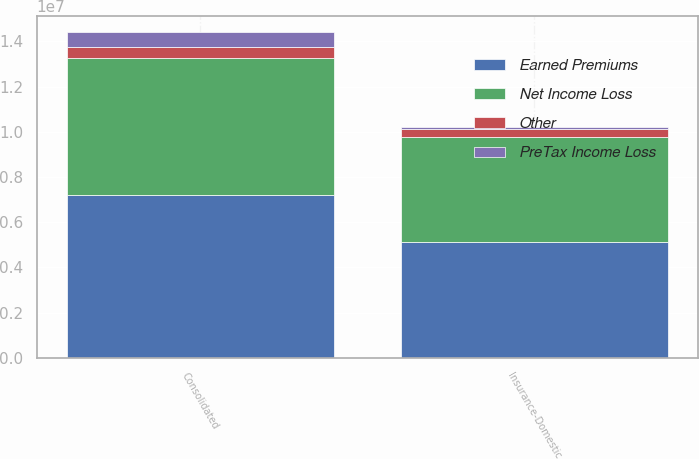Convert chart. <chart><loc_0><loc_0><loc_500><loc_500><stacked_bar_chart><ecel><fcel>Insurance-Domestic<fcel>Consolidated<nl><fcel>Net Income Loss<fcel>4.65936e+06<fcel>6.04061e+06<nl><fcel>Other<fcel>358935<fcel>512645<nl><fcel>PreTax Income Loss<fcel>96487<fcel>653203<nl><fcel>Earned Premiums<fcel>5.11478e+06<fcel>7.20646e+06<nl></chart> 